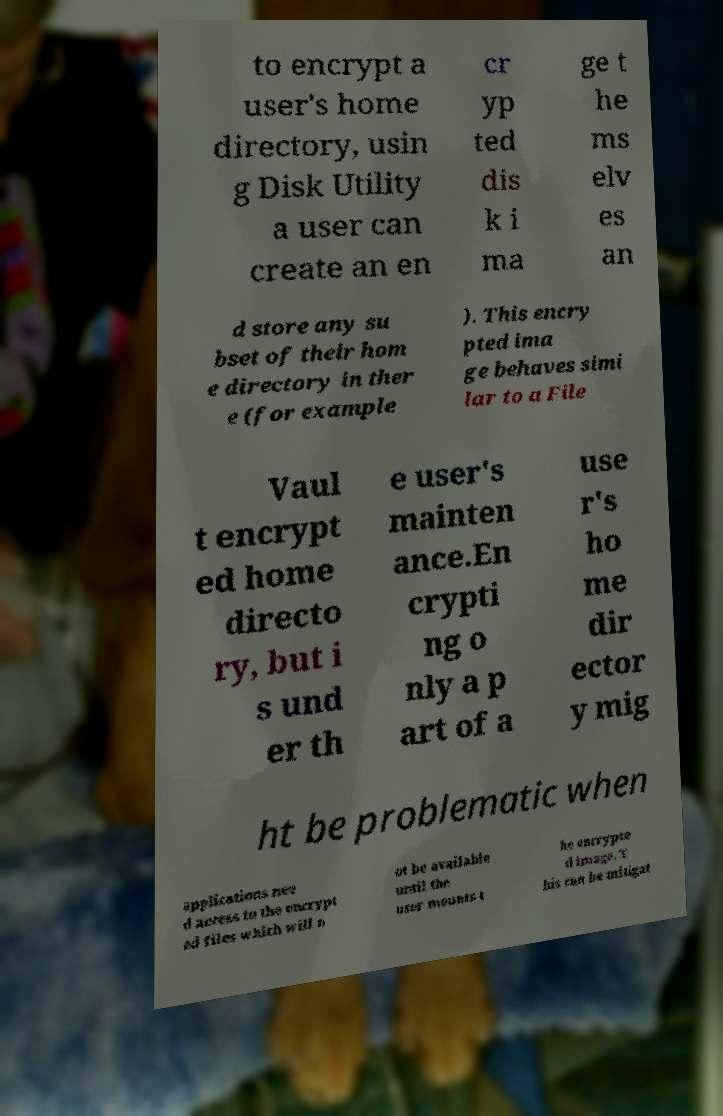Could you extract and type out the text from this image? to encrypt a user's home directory, usin g Disk Utility a user can create an en cr yp ted dis k i ma ge t he ms elv es an d store any su bset of their hom e directory in ther e (for example ). This encry pted ima ge behaves simi lar to a File Vaul t encrypt ed home directo ry, but i s und er th e user's mainten ance.En crypti ng o nly a p art of a use r's ho me dir ector y mig ht be problematic when applications nee d access to the encrypt ed files which will n ot be available until the user mounts t he encrypte d image. T his can be mitigat 